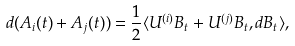Convert formula to latex. <formula><loc_0><loc_0><loc_500><loc_500>& d ( A _ { i } ( t ) + A _ { j } ( t ) ) = \frac { 1 } { 2 } \langle U ^ { ( i ) } B _ { t } + U ^ { ( j ) } B _ { t } , d B _ { t } \rangle ,</formula> 